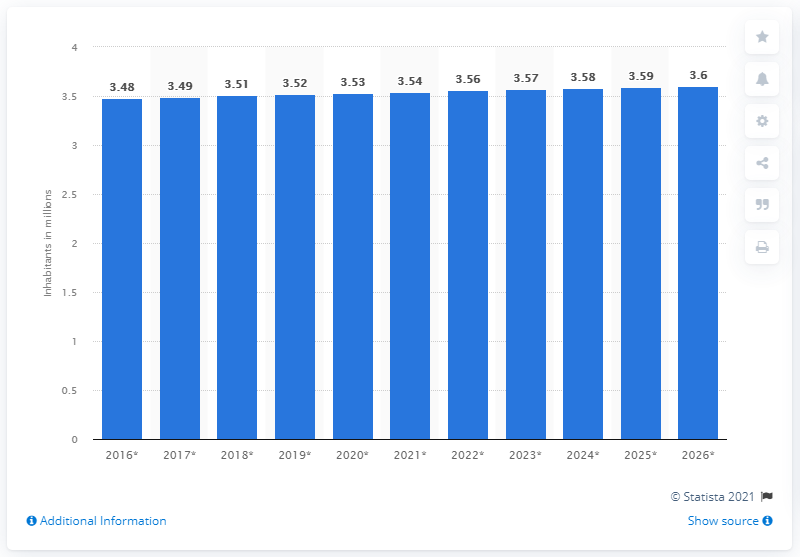Mention a couple of crucial points in this snapshot. In 2020, the population of Uruguay was approximately 3.56 million. 